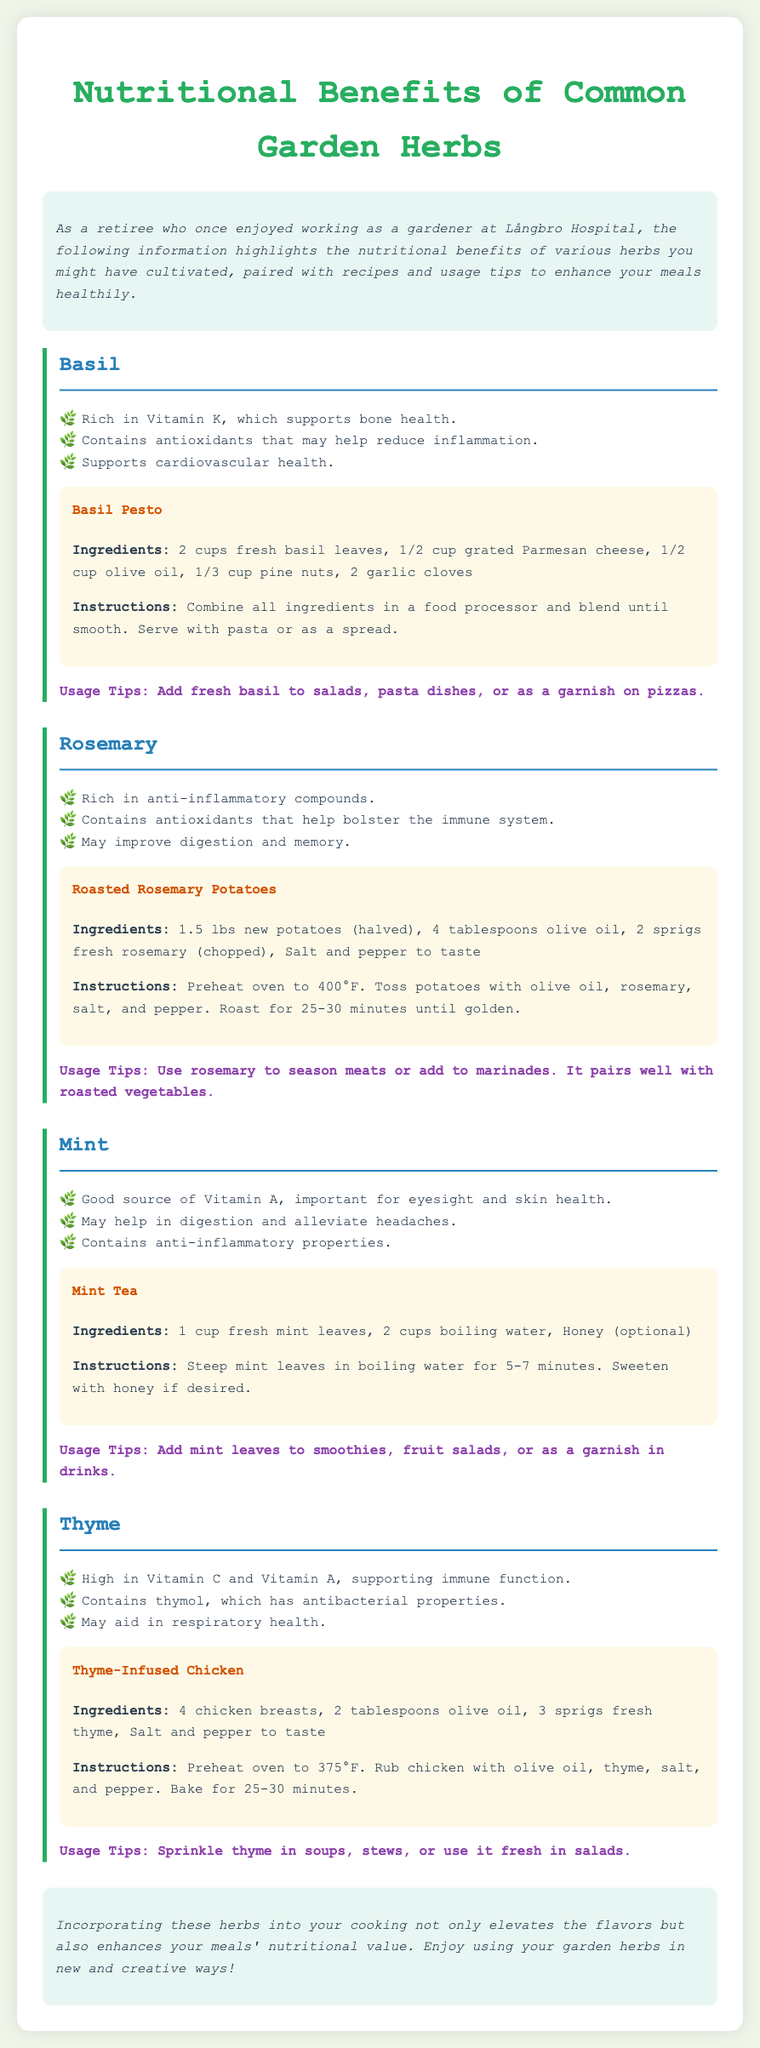What is the main focus of the document? The document highlights the nutritional benefits of various herbs commonly grown in gardens, along with recipes and usage tips.
Answer: Nutritional benefits of herbs How many herbs are discussed in the document? There are four herbs mentioned: Basil, Rosemary, Mint, and Thyme.
Answer: Four What is a nutritional benefit of Basil? Basil is rich in Vitamin K, which supports bone health.
Answer: Vitamin K What is the recipe included for Mint? The recipe included for Mint is Mint Tea.
Answer: Mint Tea What is a usage tip for Rosemary? Use rosemary to season meats or add to marinades.
Answer: Season meats What vitamin is high in Thyme? Thyme is high in Vitamin C and Vitamin A.
Answer: Vitamin C and Vitamin A What type of meal can you use Basil Pesto for? Basil Pesto can be served with pasta or as a spread.
Answer: Pasta or as a spread How long should Mint leaves steep for the tea recipe? Mint leaves should steep for 5-7 minutes.
Answer: 5-7 minutes What cooking method is suggested for the Thyme-Infused Chicken? The suggested cooking method is baking.
Answer: Baking 